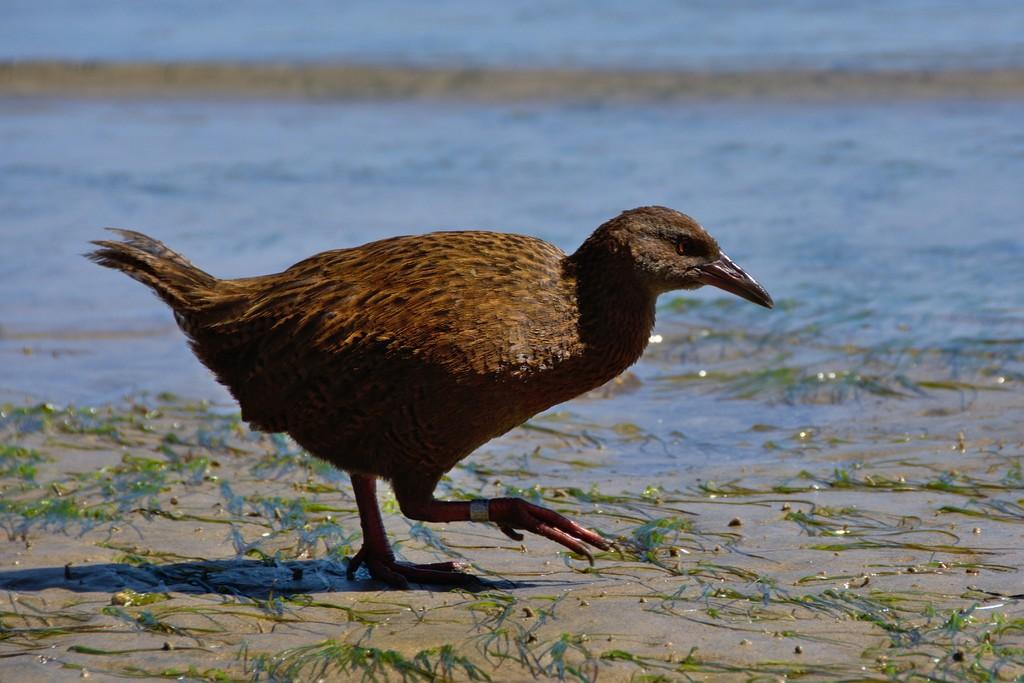What animal is present in the image? There is a hen in the image. What is the hen doing in the image? The hen is walking on a surface in the image. What type of vegetation can be seen in the image? There is grass visible in the image. What can be seen in the background of the image? There is water visible in the background of the image. What type of record is the hen holding in the image? There is no record present in the image; the hen is walking on a surface and there is grass and water visible in the image. 